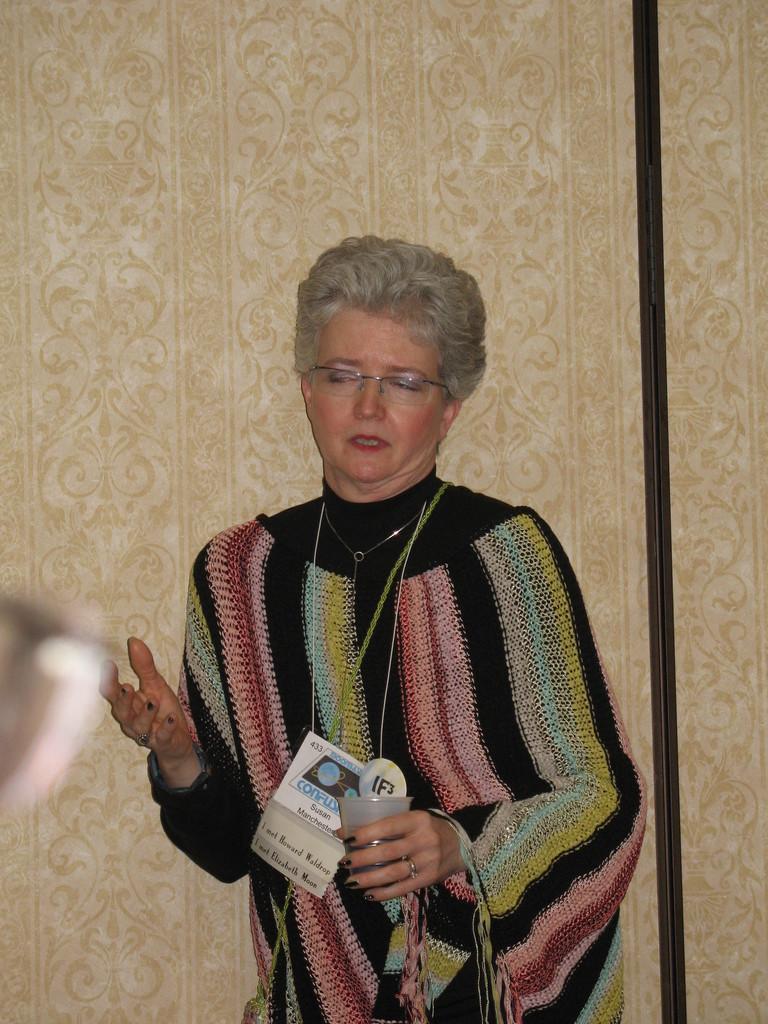Could you give a brief overview of what you see in this image? There is a woman standing and holding a glass and wire tag,behind her we can see wall. 